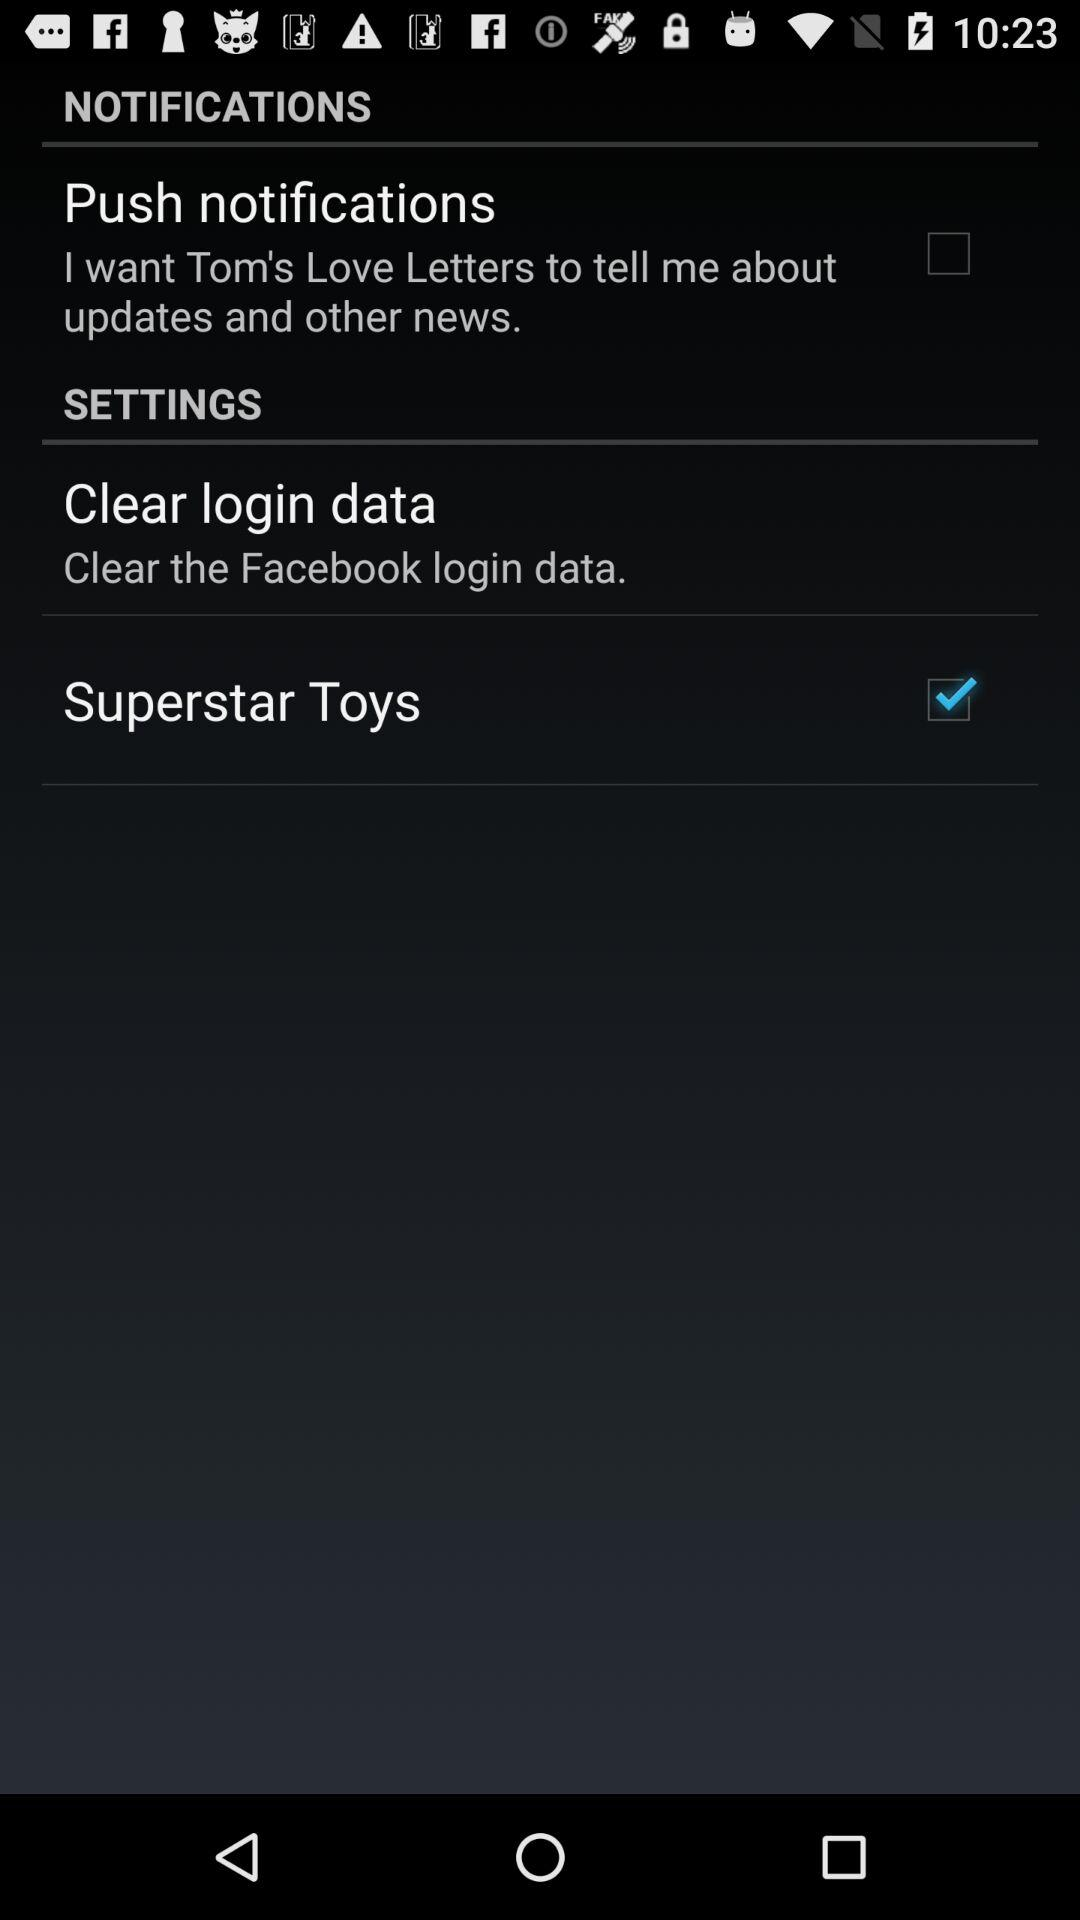What's the checked setting? The checked setting is "Superstar Toys". 